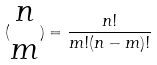<formula> <loc_0><loc_0><loc_500><loc_500>( \begin{matrix} n \\ m \end{matrix} ) = \frac { n ! } { m ! ( n - m ) ! }</formula> 